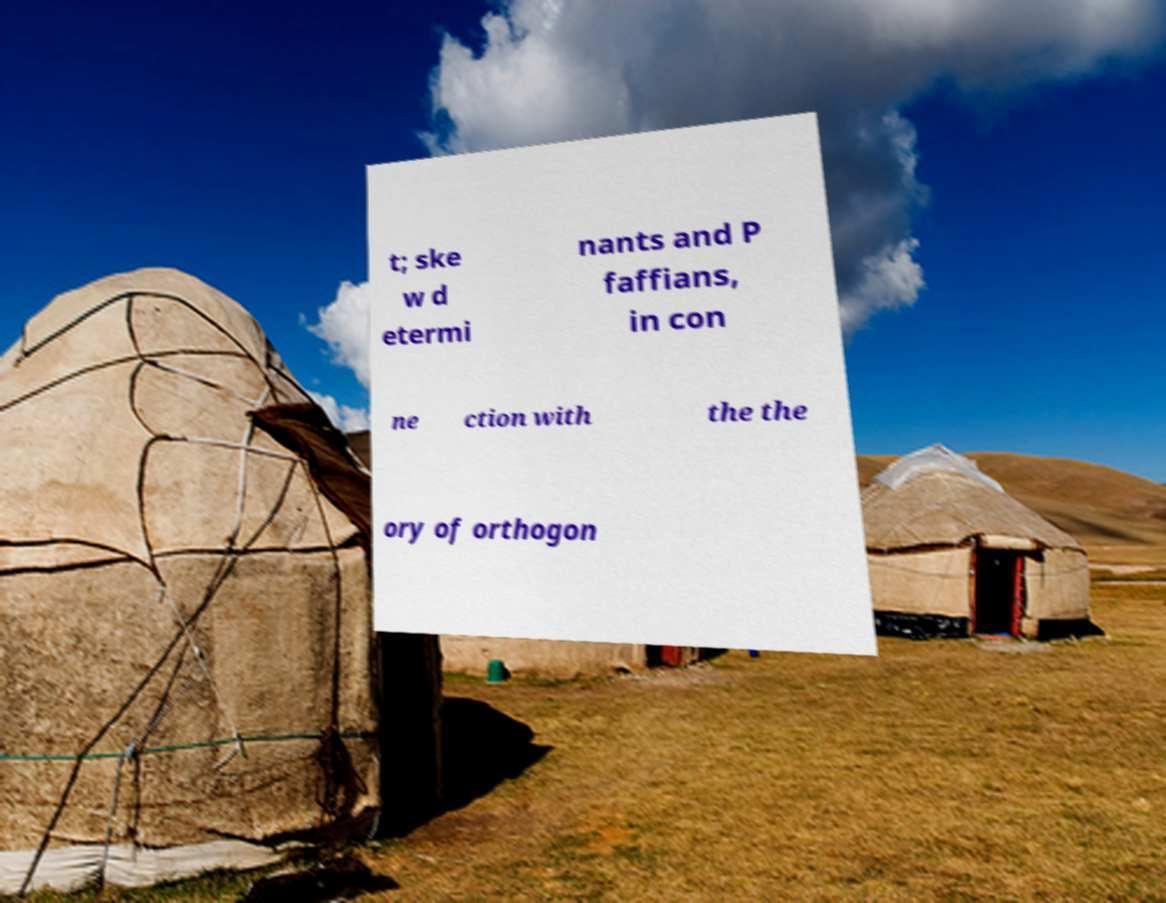There's text embedded in this image that I need extracted. Can you transcribe it verbatim? t; ske w d etermi nants and P faffians, in con ne ction with the the ory of orthogon 